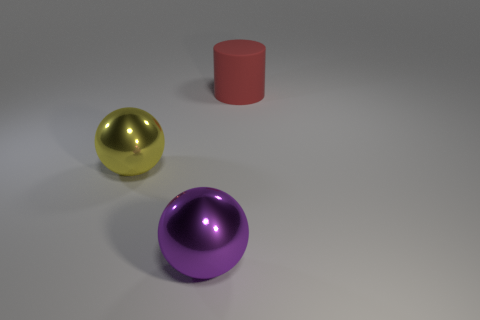Add 2 purple metal things. How many objects exist? 5 Subtract all cylinders. How many objects are left? 2 Add 1 small green cylinders. How many small green cylinders exist? 1 Subtract 0 red blocks. How many objects are left? 3 Subtract all matte objects. Subtract all big yellow spheres. How many objects are left? 1 Add 1 big red cylinders. How many big red cylinders are left? 2 